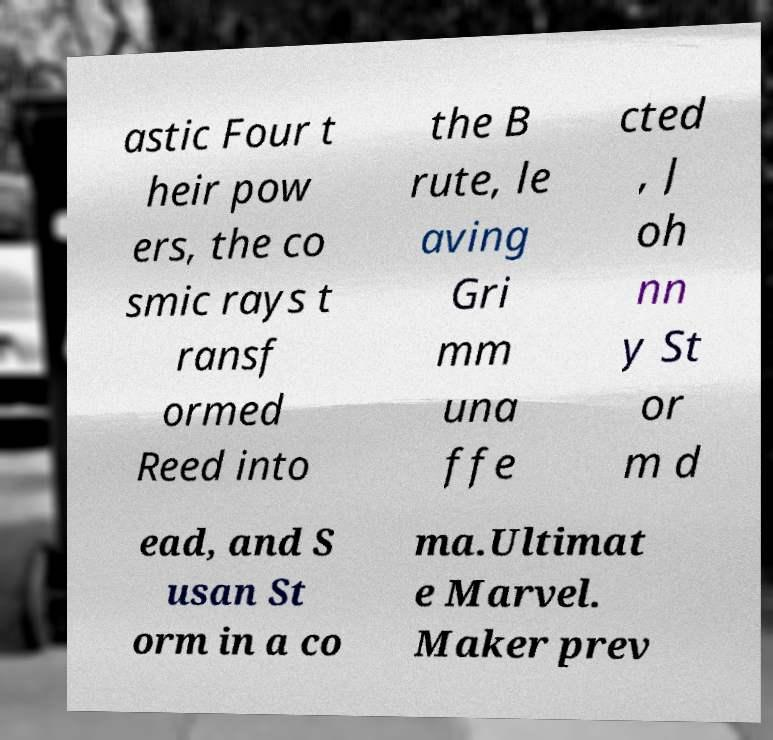Can you read and provide the text displayed in the image?This photo seems to have some interesting text. Can you extract and type it out for me? astic Four t heir pow ers, the co smic rays t ransf ormed Reed into the B rute, le aving Gri mm una ffe cted , J oh nn y St or m d ead, and S usan St orm in a co ma.Ultimat e Marvel. Maker prev 